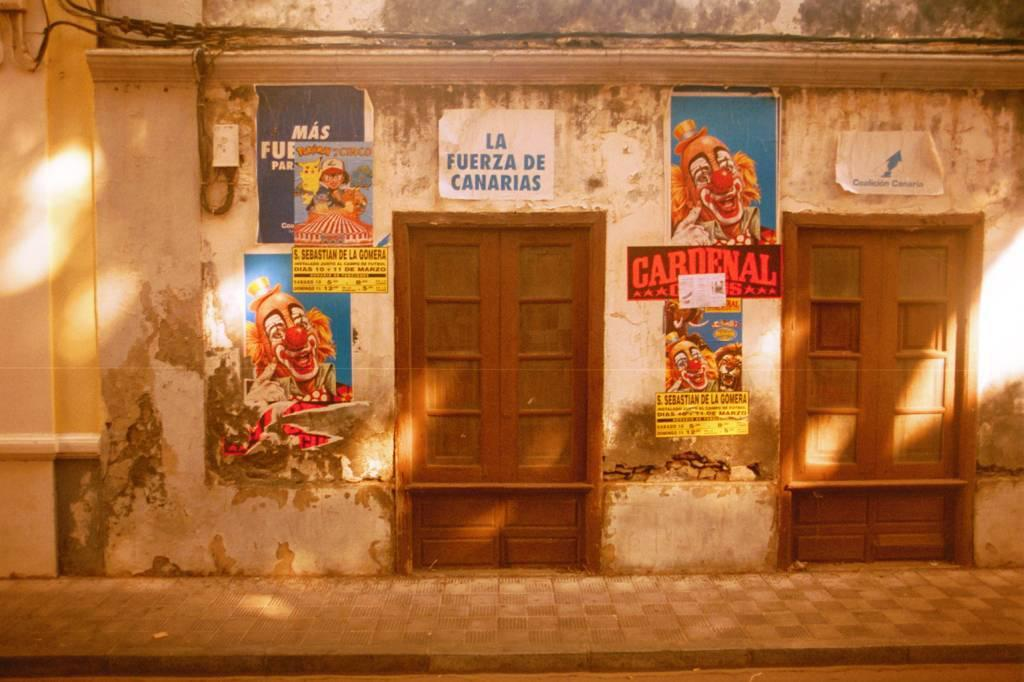What is the main structure visible in the foreground of the image? There is a building in the foreground of the image. What features can be seen on the building in the image? There are doors and posters in the foreground of the image. What else is present in the foreground of the image? There are wires in the foreground of the image. What time of day was the image taken? The image was taken during nighttime. What type of prose can be seen on the kittens in the image? There are no kittens present in the image, and therefore no prose can be seen on them. 